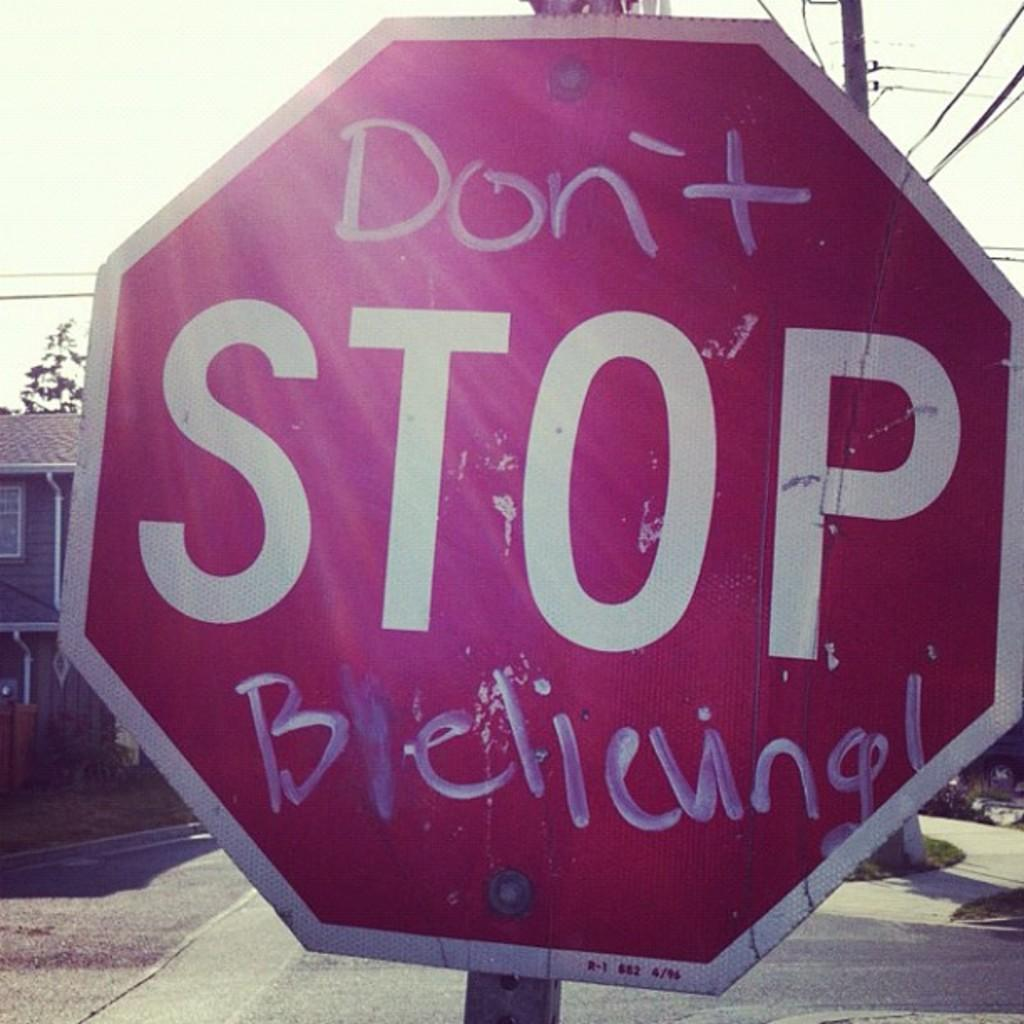<image>
Give a short and clear explanation of the subsequent image. A vandalized red stop sign that says "don't stop believing". 